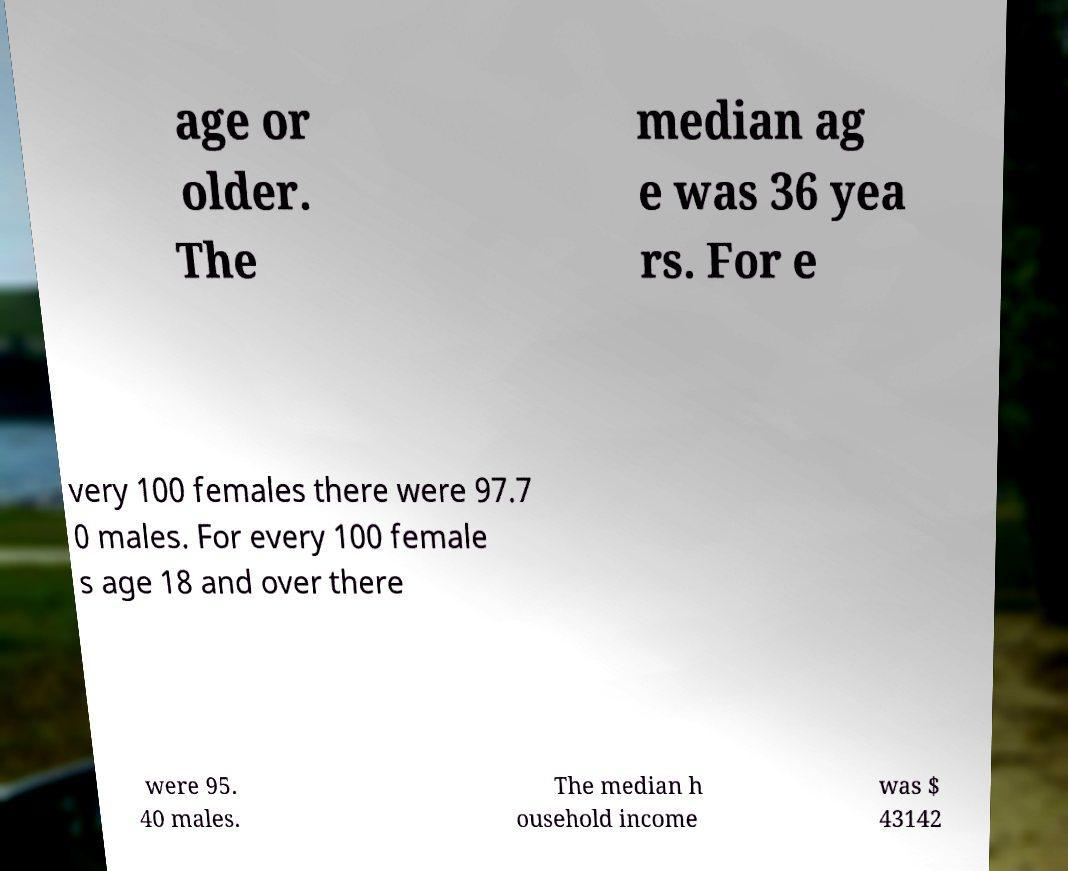I need the written content from this picture converted into text. Can you do that? age or older. The median ag e was 36 yea rs. For e very 100 females there were 97.7 0 males. For every 100 female s age 18 and over there were 95. 40 males. The median h ousehold income was $ 43142 